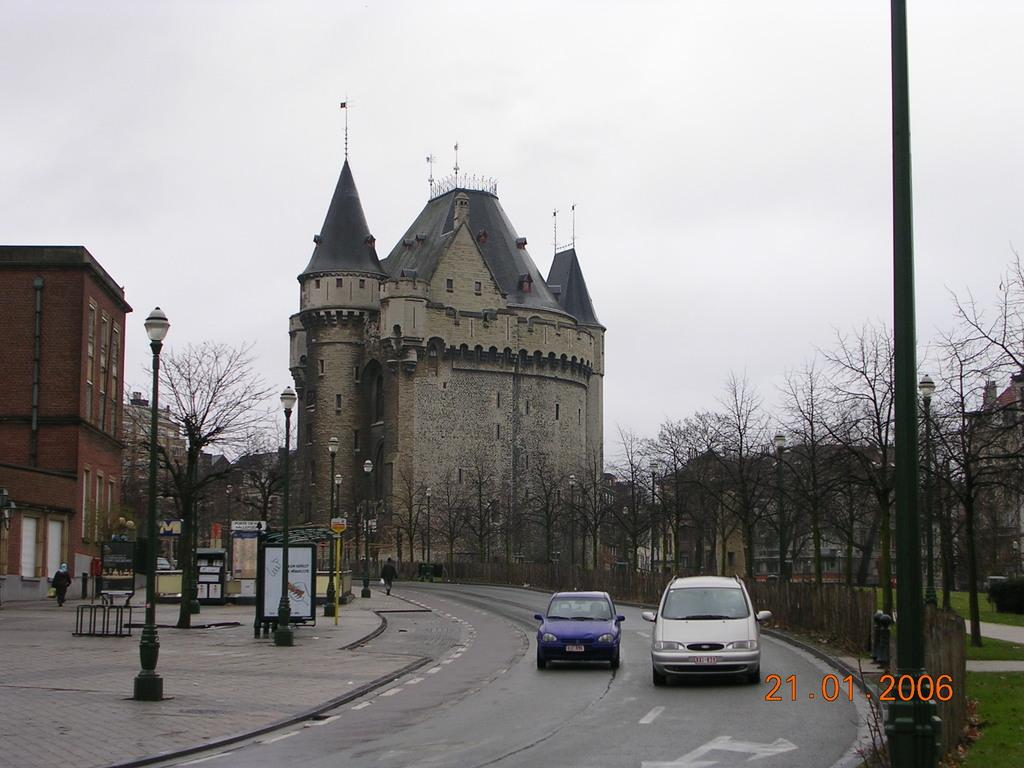What type of structures can be seen in the image? There are buildings in the image. What feature of the buildings is visible? Windows are visible in the image. What type of vegetation is present in the image? Dry trees are present in the image. What type of signage is visible in the image? Sign boards are present in the image. What type of poles are visible in the image? Light poles are present in the image. Are there any people in the image? Yes, there are people in the image. What part of the natural environment is visible in the image? The sky is visible in the image. What type of transportation is present on the road in the image? Vehicles are present on the road in the image. How many mint leaves are on the light poles in the image? There are no mint leaves present on the light poles in the image. How long does it take for the minute hand to move one minute in the image? There is no clock or time-related element in the image, so it's not possible to determine the movement of a minute hand. 